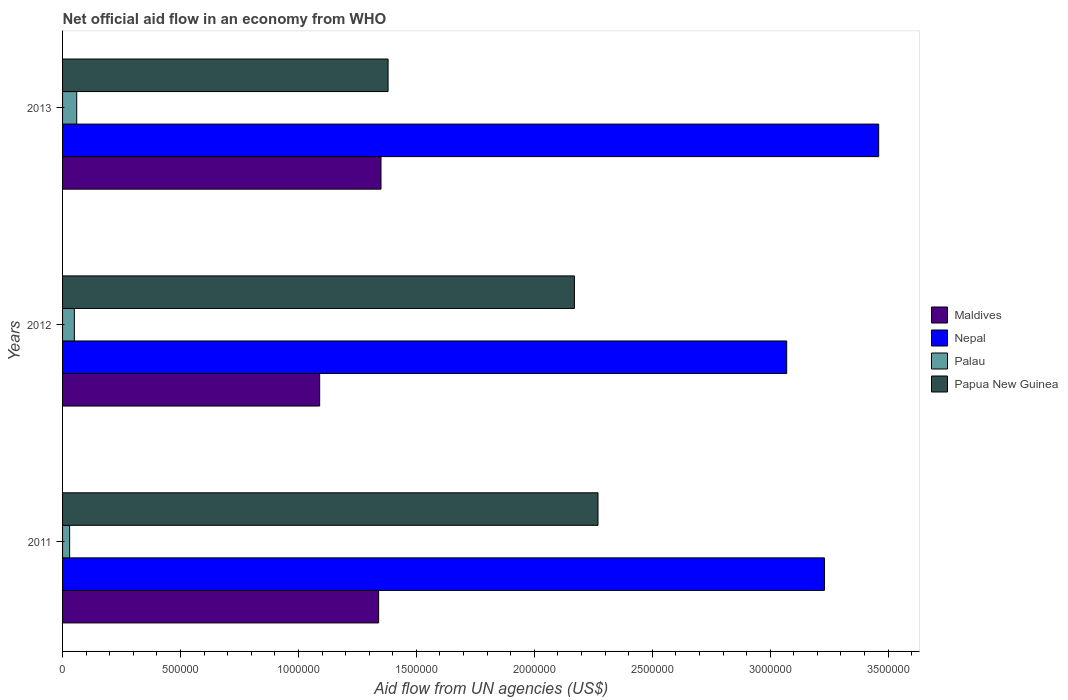How many different coloured bars are there?
Your answer should be very brief. 4. Are the number of bars on each tick of the Y-axis equal?
Your answer should be compact. Yes. How many bars are there on the 2nd tick from the bottom?
Your response must be concise. 4. What is the label of the 2nd group of bars from the top?
Give a very brief answer. 2012. What is the net official aid flow in Nepal in 2012?
Give a very brief answer. 3.07e+06. Across all years, what is the maximum net official aid flow in Nepal?
Keep it short and to the point. 3.46e+06. Across all years, what is the minimum net official aid flow in Nepal?
Your response must be concise. 3.07e+06. In which year was the net official aid flow in Nepal maximum?
Your answer should be very brief. 2013. In which year was the net official aid flow in Papua New Guinea minimum?
Keep it short and to the point. 2013. What is the total net official aid flow in Nepal in the graph?
Ensure brevity in your answer.  9.76e+06. What is the difference between the net official aid flow in Palau in 2011 and that in 2012?
Offer a terse response. -2.00e+04. What is the difference between the net official aid flow in Nepal in 2011 and the net official aid flow in Papua New Guinea in 2012?
Your answer should be compact. 1.06e+06. What is the average net official aid flow in Palau per year?
Provide a succinct answer. 4.67e+04. What is the ratio of the net official aid flow in Nepal in 2012 to that in 2013?
Give a very brief answer. 0.89. Is the difference between the net official aid flow in Maldives in 2011 and 2012 greater than the difference between the net official aid flow in Papua New Guinea in 2011 and 2012?
Make the answer very short. Yes. What is the difference between the highest and the lowest net official aid flow in Maldives?
Offer a very short reply. 2.60e+05. Is the sum of the net official aid flow in Nepal in 2011 and 2013 greater than the maximum net official aid flow in Papua New Guinea across all years?
Offer a terse response. Yes. What does the 2nd bar from the top in 2011 represents?
Provide a succinct answer. Palau. What does the 3rd bar from the bottom in 2012 represents?
Offer a very short reply. Palau. How many years are there in the graph?
Provide a short and direct response. 3. What is the difference between two consecutive major ticks on the X-axis?
Give a very brief answer. 5.00e+05. Does the graph contain grids?
Provide a succinct answer. No. How many legend labels are there?
Your answer should be very brief. 4. How are the legend labels stacked?
Provide a succinct answer. Vertical. What is the title of the graph?
Your response must be concise. Net official aid flow in an economy from WHO. Does "Turks and Caicos Islands" appear as one of the legend labels in the graph?
Give a very brief answer. No. What is the label or title of the X-axis?
Make the answer very short. Aid flow from UN agencies (US$). What is the Aid flow from UN agencies (US$) in Maldives in 2011?
Provide a succinct answer. 1.34e+06. What is the Aid flow from UN agencies (US$) of Nepal in 2011?
Your answer should be very brief. 3.23e+06. What is the Aid flow from UN agencies (US$) of Papua New Guinea in 2011?
Make the answer very short. 2.27e+06. What is the Aid flow from UN agencies (US$) in Maldives in 2012?
Make the answer very short. 1.09e+06. What is the Aid flow from UN agencies (US$) of Nepal in 2012?
Your response must be concise. 3.07e+06. What is the Aid flow from UN agencies (US$) in Palau in 2012?
Offer a very short reply. 5.00e+04. What is the Aid flow from UN agencies (US$) of Papua New Guinea in 2012?
Give a very brief answer. 2.17e+06. What is the Aid flow from UN agencies (US$) of Maldives in 2013?
Provide a succinct answer. 1.35e+06. What is the Aid flow from UN agencies (US$) of Nepal in 2013?
Provide a succinct answer. 3.46e+06. What is the Aid flow from UN agencies (US$) in Palau in 2013?
Give a very brief answer. 6.00e+04. What is the Aid flow from UN agencies (US$) in Papua New Guinea in 2013?
Your answer should be compact. 1.38e+06. Across all years, what is the maximum Aid flow from UN agencies (US$) of Maldives?
Give a very brief answer. 1.35e+06. Across all years, what is the maximum Aid flow from UN agencies (US$) in Nepal?
Keep it short and to the point. 3.46e+06. Across all years, what is the maximum Aid flow from UN agencies (US$) in Papua New Guinea?
Give a very brief answer. 2.27e+06. Across all years, what is the minimum Aid flow from UN agencies (US$) in Maldives?
Your answer should be compact. 1.09e+06. Across all years, what is the minimum Aid flow from UN agencies (US$) of Nepal?
Your answer should be very brief. 3.07e+06. Across all years, what is the minimum Aid flow from UN agencies (US$) in Papua New Guinea?
Your answer should be very brief. 1.38e+06. What is the total Aid flow from UN agencies (US$) in Maldives in the graph?
Give a very brief answer. 3.78e+06. What is the total Aid flow from UN agencies (US$) in Nepal in the graph?
Provide a succinct answer. 9.76e+06. What is the total Aid flow from UN agencies (US$) of Papua New Guinea in the graph?
Ensure brevity in your answer.  5.82e+06. What is the difference between the Aid flow from UN agencies (US$) in Maldives in 2011 and that in 2012?
Offer a terse response. 2.50e+05. What is the difference between the Aid flow from UN agencies (US$) in Nepal in 2011 and that in 2012?
Your response must be concise. 1.60e+05. What is the difference between the Aid flow from UN agencies (US$) of Palau in 2011 and that in 2012?
Give a very brief answer. -2.00e+04. What is the difference between the Aid flow from UN agencies (US$) of Papua New Guinea in 2011 and that in 2012?
Offer a terse response. 1.00e+05. What is the difference between the Aid flow from UN agencies (US$) of Nepal in 2011 and that in 2013?
Give a very brief answer. -2.30e+05. What is the difference between the Aid flow from UN agencies (US$) in Palau in 2011 and that in 2013?
Make the answer very short. -3.00e+04. What is the difference between the Aid flow from UN agencies (US$) in Papua New Guinea in 2011 and that in 2013?
Offer a very short reply. 8.90e+05. What is the difference between the Aid flow from UN agencies (US$) of Nepal in 2012 and that in 2013?
Keep it short and to the point. -3.90e+05. What is the difference between the Aid flow from UN agencies (US$) of Palau in 2012 and that in 2013?
Provide a succinct answer. -10000. What is the difference between the Aid flow from UN agencies (US$) in Papua New Guinea in 2012 and that in 2013?
Your response must be concise. 7.90e+05. What is the difference between the Aid flow from UN agencies (US$) in Maldives in 2011 and the Aid flow from UN agencies (US$) in Nepal in 2012?
Your answer should be very brief. -1.73e+06. What is the difference between the Aid flow from UN agencies (US$) of Maldives in 2011 and the Aid flow from UN agencies (US$) of Palau in 2012?
Offer a very short reply. 1.29e+06. What is the difference between the Aid flow from UN agencies (US$) of Maldives in 2011 and the Aid flow from UN agencies (US$) of Papua New Guinea in 2012?
Offer a very short reply. -8.30e+05. What is the difference between the Aid flow from UN agencies (US$) in Nepal in 2011 and the Aid flow from UN agencies (US$) in Palau in 2012?
Make the answer very short. 3.18e+06. What is the difference between the Aid flow from UN agencies (US$) of Nepal in 2011 and the Aid flow from UN agencies (US$) of Papua New Guinea in 2012?
Make the answer very short. 1.06e+06. What is the difference between the Aid flow from UN agencies (US$) in Palau in 2011 and the Aid flow from UN agencies (US$) in Papua New Guinea in 2012?
Make the answer very short. -2.14e+06. What is the difference between the Aid flow from UN agencies (US$) in Maldives in 2011 and the Aid flow from UN agencies (US$) in Nepal in 2013?
Your answer should be compact. -2.12e+06. What is the difference between the Aid flow from UN agencies (US$) in Maldives in 2011 and the Aid flow from UN agencies (US$) in Palau in 2013?
Offer a very short reply. 1.28e+06. What is the difference between the Aid flow from UN agencies (US$) of Maldives in 2011 and the Aid flow from UN agencies (US$) of Papua New Guinea in 2013?
Make the answer very short. -4.00e+04. What is the difference between the Aid flow from UN agencies (US$) in Nepal in 2011 and the Aid flow from UN agencies (US$) in Palau in 2013?
Provide a short and direct response. 3.17e+06. What is the difference between the Aid flow from UN agencies (US$) of Nepal in 2011 and the Aid flow from UN agencies (US$) of Papua New Guinea in 2013?
Provide a succinct answer. 1.85e+06. What is the difference between the Aid flow from UN agencies (US$) of Palau in 2011 and the Aid flow from UN agencies (US$) of Papua New Guinea in 2013?
Your answer should be compact. -1.35e+06. What is the difference between the Aid flow from UN agencies (US$) in Maldives in 2012 and the Aid flow from UN agencies (US$) in Nepal in 2013?
Keep it short and to the point. -2.37e+06. What is the difference between the Aid flow from UN agencies (US$) in Maldives in 2012 and the Aid flow from UN agencies (US$) in Palau in 2013?
Provide a short and direct response. 1.03e+06. What is the difference between the Aid flow from UN agencies (US$) of Maldives in 2012 and the Aid flow from UN agencies (US$) of Papua New Guinea in 2013?
Your answer should be very brief. -2.90e+05. What is the difference between the Aid flow from UN agencies (US$) in Nepal in 2012 and the Aid flow from UN agencies (US$) in Palau in 2013?
Provide a succinct answer. 3.01e+06. What is the difference between the Aid flow from UN agencies (US$) in Nepal in 2012 and the Aid flow from UN agencies (US$) in Papua New Guinea in 2013?
Give a very brief answer. 1.69e+06. What is the difference between the Aid flow from UN agencies (US$) in Palau in 2012 and the Aid flow from UN agencies (US$) in Papua New Guinea in 2013?
Your response must be concise. -1.33e+06. What is the average Aid flow from UN agencies (US$) of Maldives per year?
Give a very brief answer. 1.26e+06. What is the average Aid flow from UN agencies (US$) in Nepal per year?
Your answer should be very brief. 3.25e+06. What is the average Aid flow from UN agencies (US$) in Palau per year?
Give a very brief answer. 4.67e+04. What is the average Aid flow from UN agencies (US$) in Papua New Guinea per year?
Keep it short and to the point. 1.94e+06. In the year 2011, what is the difference between the Aid flow from UN agencies (US$) of Maldives and Aid flow from UN agencies (US$) of Nepal?
Offer a terse response. -1.89e+06. In the year 2011, what is the difference between the Aid flow from UN agencies (US$) of Maldives and Aid flow from UN agencies (US$) of Palau?
Provide a succinct answer. 1.31e+06. In the year 2011, what is the difference between the Aid flow from UN agencies (US$) of Maldives and Aid flow from UN agencies (US$) of Papua New Guinea?
Offer a terse response. -9.30e+05. In the year 2011, what is the difference between the Aid flow from UN agencies (US$) of Nepal and Aid flow from UN agencies (US$) of Palau?
Give a very brief answer. 3.20e+06. In the year 2011, what is the difference between the Aid flow from UN agencies (US$) of Nepal and Aid flow from UN agencies (US$) of Papua New Guinea?
Your answer should be very brief. 9.60e+05. In the year 2011, what is the difference between the Aid flow from UN agencies (US$) in Palau and Aid flow from UN agencies (US$) in Papua New Guinea?
Give a very brief answer. -2.24e+06. In the year 2012, what is the difference between the Aid flow from UN agencies (US$) in Maldives and Aid flow from UN agencies (US$) in Nepal?
Give a very brief answer. -1.98e+06. In the year 2012, what is the difference between the Aid flow from UN agencies (US$) in Maldives and Aid flow from UN agencies (US$) in Palau?
Offer a terse response. 1.04e+06. In the year 2012, what is the difference between the Aid flow from UN agencies (US$) in Maldives and Aid flow from UN agencies (US$) in Papua New Guinea?
Offer a terse response. -1.08e+06. In the year 2012, what is the difference between the Aid flow from UN agencies (US$) in Nepal and Aid flow from UN agencies (US$) in Palau?
Offer a terse response. 3.02e+06. In the year 2012, what is the difference between the Aid flow from UN agencies (US$) in Palau and Aid flow from UN agencies (US$) in Papua New Guinea?
Your response must be concise. -2.12e+06. In the year 2013, what is the difference between the Aid flow from UN agencies (US$) in Maldives and Aid flow from UN agencies (US$) in Nepal?
Provide a short and direct response. -2.11e+06. In the year 2013, what is the difference between the Aid flow from UN agencies (US$) of Maldives and Aid flow from UN agencies (US$) of Palau?
Offer a very short reply. 1.29e+06. In the year 2013, what is the difference between the Aid flow from UN agencies (US$) in Maldives and Aid flow from UN agencies (US$) in Papua New Guinea?
Provide a short and direct response. -3.00e+04. In the year 2013, what is the difference between the Aid flow from UN agencies (US$) of Nepal and Aid flow from UN agencies (US$) of Palau?
Ensure brevity in your answer.  3.40e+06. In the year 2013, what is the difference between the Aid flow from UN agencies (US$) in Nepal and Aid flow from UN agencies (US$) in Papua New Guinea?
Offer a terse response. 2.08e+06. In the year 2013, what is the difference between the Aid flow from UN agencies (US$) of Palau and Aid flow from UN agencies (US$) of Papua New Guinea?
Your answer should be very brief. -1.32e+06. What is the ratio of the Aid flow from UN agencies (US$) of Maldives in 2011 to that in 2012?
Offer a terse response. 1.23. What is the ratio of the Aid flow from UN agencies (US$) of Nepal in 2011 to that in 2012?
Your answer should be compact. 1.05. What is the ratio of the Aid flow from UN agencies (US$) of Palau in 2011 to that in 2012?
Provide a short and direct response. 0.6. What is the ratio of the Aid flow from UN agencies (US$) in Papua New Guinea in 2011 to that in 2012?
Provide a succinct answer. 1.05. What is the ratio of the Aid flow from UN agencies (US$) of Nepal in 2011 to that in 2013?
Ensure brevity in your answer.  0.93. What is the ratio of the Aid flow from UN agencies (US$) in Papua New Guinea in 2011 to that in 2013?
Ensure brevity in your answer.  1.64. What is the ratio of the Aid flow from UN agencies (US$) of Maldives in 2012 to that in 2013?
Ensure brevity in your answer.  0.81. What is the ratio of the Aid flow from UN agencies (US$) of Nepal in 2012 to that in 2013?
Ensure brevity in your answer.  0.89. What is the ratio of the Aid flow from UN agencies (US$) of Palau in 2012 to that in 2013?
Make the answer very short. 0.83. What is the ratio of the Aid flow from UN agencies (US$) in Papua New Guinea in 2012 to that in 2013?
Offer a very short reply. 1.57. What is the difference between the highest and the second highest Aid flow from UN agencies (US$) of Maldives?
Keep it short and to the point. 10000. What is the difference between the highest and the second highest Aid flow from UN agencies (US$) of Nepal?
Ensure brevity in your answer.  2.30e+05. What is the difference between the highest and the lowest Aid flow from UN agencies (US$) of Palau?
Offer a terse response. 3.00e+04. What is the difference between the highest and the lowest Aid flow from UN agencies (US$) of Papua New Guinea?
Give a very brief answer. 8.90e+05. 